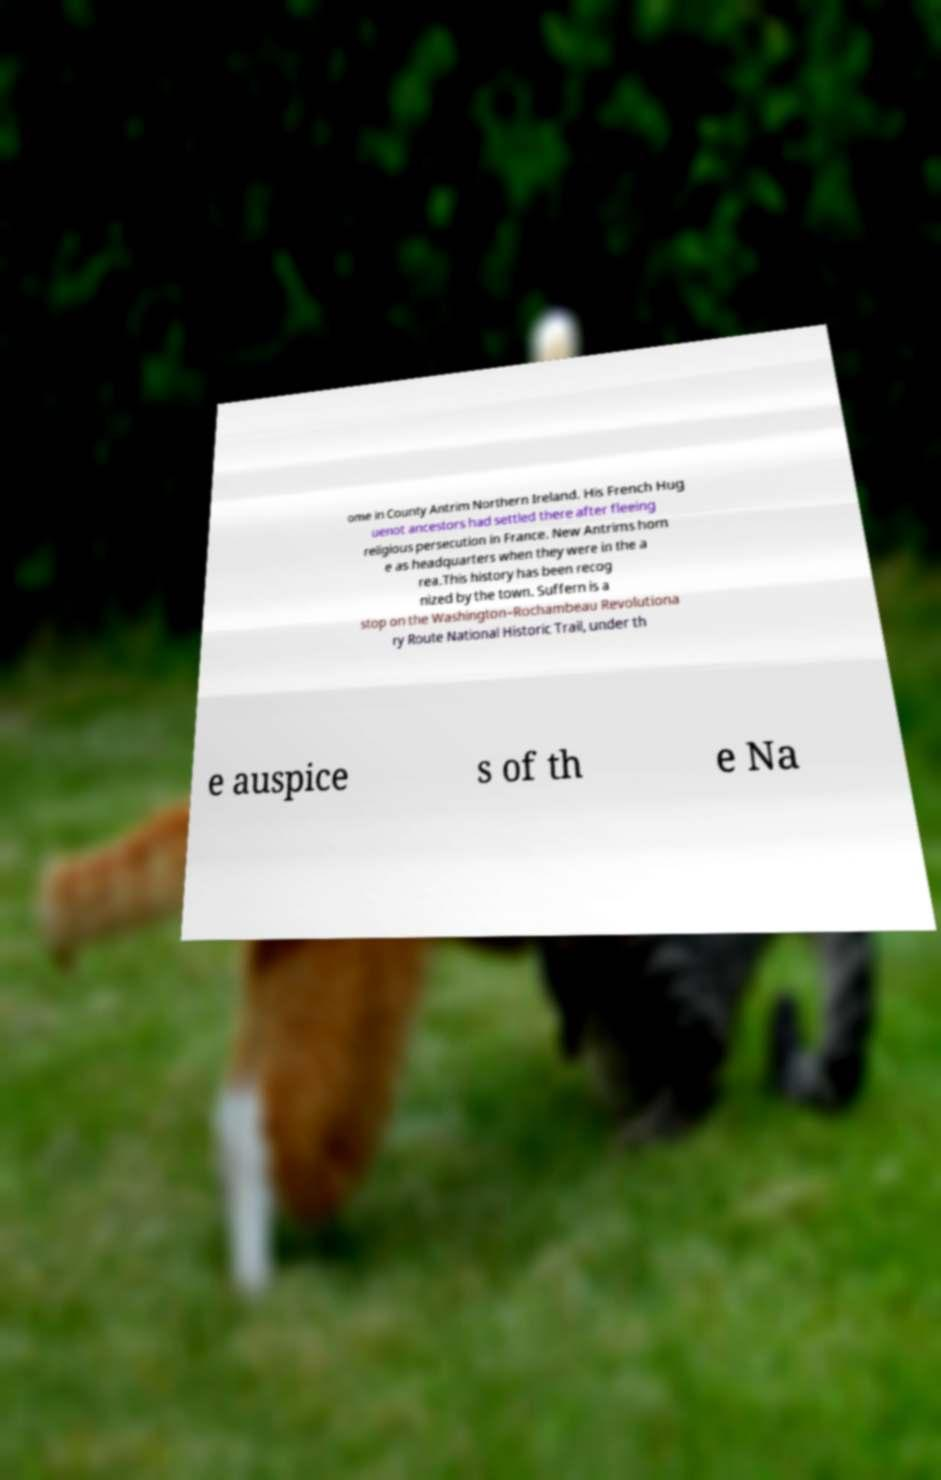Please identify and transcribe the text found in this image. ome in County Antrim Northern Ireland. His French Hug uenot ancestors had settled there after fleeing religious persecution in France. New Antrims hom e as headquarters when they were in the a rea.This history has been recog nized by the town. Suffern is a stop on the Washington–Rochambeau Revolutiona ry Route National Historic Trail, under th e auspice s of th e Na 